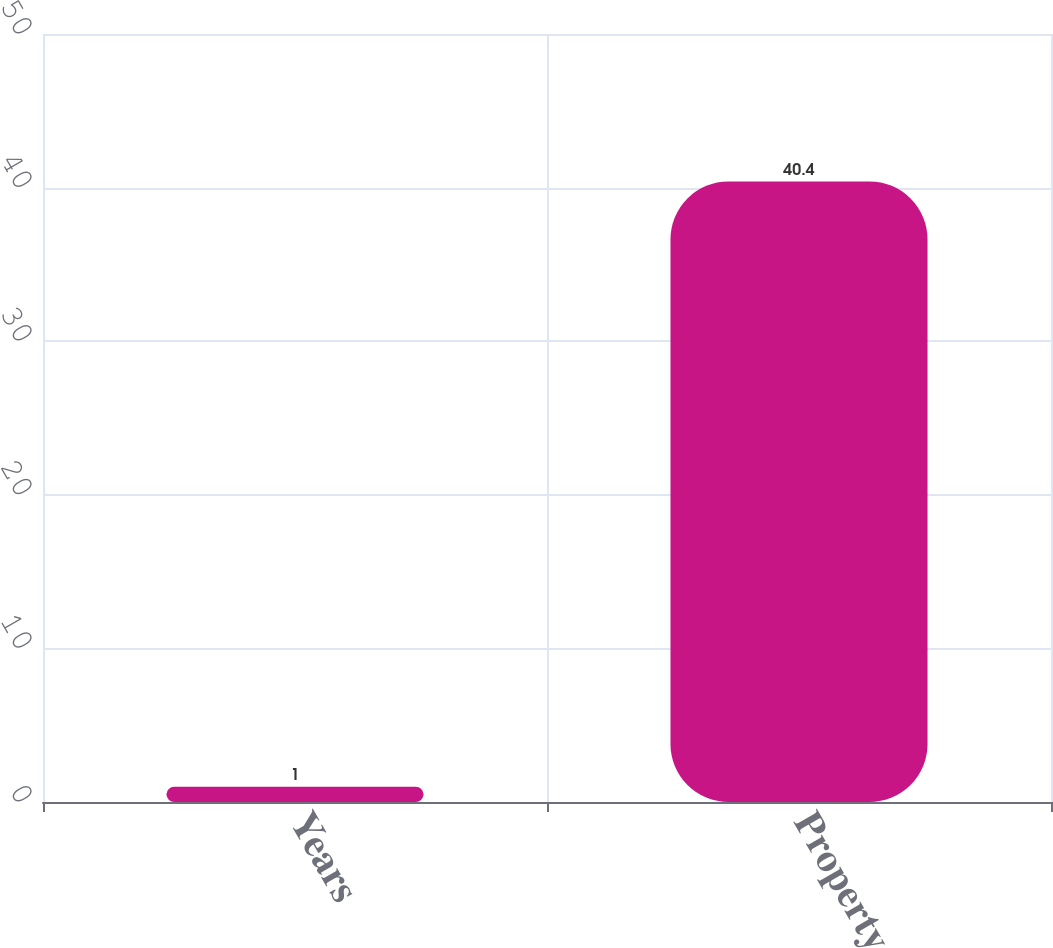Convert chart. <chart><loc_0><loc_0><loc_500><loc_500><bar_chart><fcel>Years<fcel>Property<nl><fcel>1<fcel>40.4<nl></chart> 